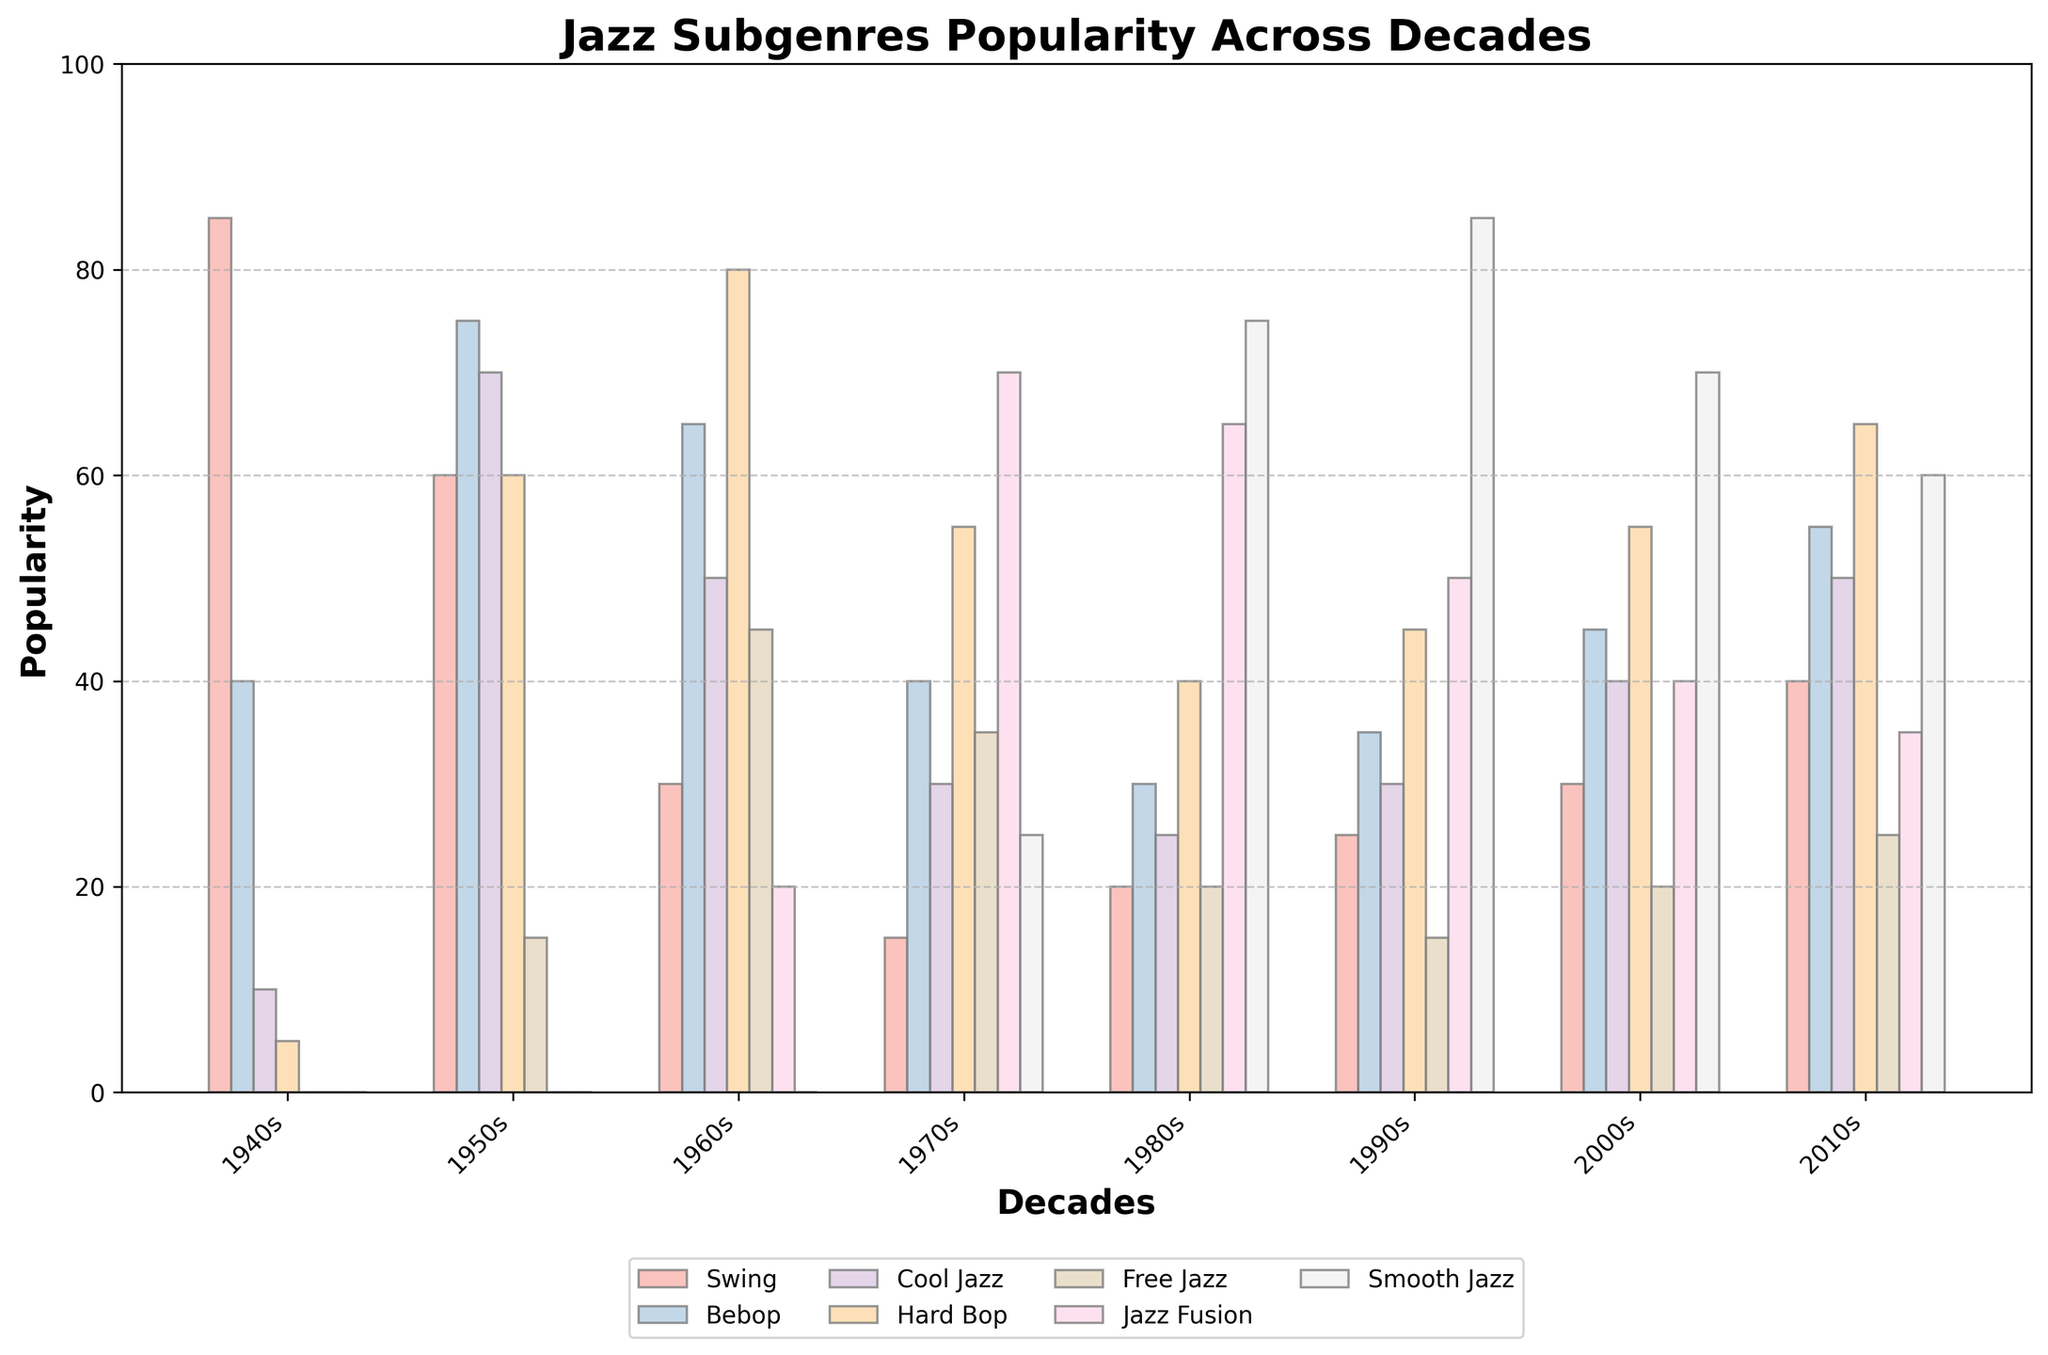Which decade saw the highest popularity of Swing? The highest bar for Swing is in the 1940s. Represented by the first set of bars, the bar is clearly the tallest among all decades for Swing.
Answer: 1940s Between Bebop and Cool Jazz, which subgenre was more popular in the 1960s? In the 1960s, the bar for Bebop is higher than the bar for Cool Jazz. Comparing the bars for each, Bebop has around 65, while Cool Jazz has around 50.
Answer: Bebop How did the popularity of Jazz Fusion change from the 1970s to the 1980s? Comparing the bars for Jazz Fusion in the 1970s and the 1980s, the height of the Jazz Fusion bar increased from approximately 70 in the 1970s to approximately 65 in the 1980s.
Answer: Decreased What was the combined popularity of Hard Bop and Smooth Jazz in the 2010s? The bar for Hard Bop in the 2010s is approximately 65, and for Smooth Jazz, it is approximately 60. Summing these two values: 65 + 60.
Answer: 125 Which subgenre had the lowest popularity in the 1950s? In the bars representing the 1950s, the bar for Free Jazz is the shortest, representing the lowest popularity.
Answer: Free Jazz Has Bebop's popularity ever been higher than Swing's popularity in any decade? Bebop's popularity in the 1950s (75) is higher than Swing's popularity in the same decade (60). This is confirmed by comparing the heights of the bars.
Answer: Yes Which subgenre experienced a rise in popularity every decade from the 1980s to the 2010s? Observing the incremental increase in bar heights from the 1980s to the 2010s, Smooth Jazz shows a consistent rise each decade (75, 85, 70, 60).
Answer: Smooth Jazz In the 1970s, which subgenre was more popular, Hard Bop or Cool Jazz? In the bars for the 1970s, the bar for Hard Bop is taller than the bar for Cool Jazz. Hard Bop is approximately 55, while Cool Jazz is approximately 30.
Answer: Hard Bop Order the subgenres by popularity in the 2000s, from highest to lowest. Observing the heights of the bars for the 2000s: Smooth Jazz (70), Hard Bop (55), Cool Jazz (40), Bebop (45), Swing (30), Jazz Fusion (40), Free Jazz (20).
Answer: Smooth Jazz > Hard Bop > Bebop = Cool Jazz > Swing = Jazz Fusion > Free Jazz Which subgenre had a decline in popularity between the 1940s and 1970s and then experienced an increase in the 1980s? Swing's popularity declined from the 1940s (85) to the 1970s (15), then increased slightly in the 1980s to 20.
Answer: Swing 